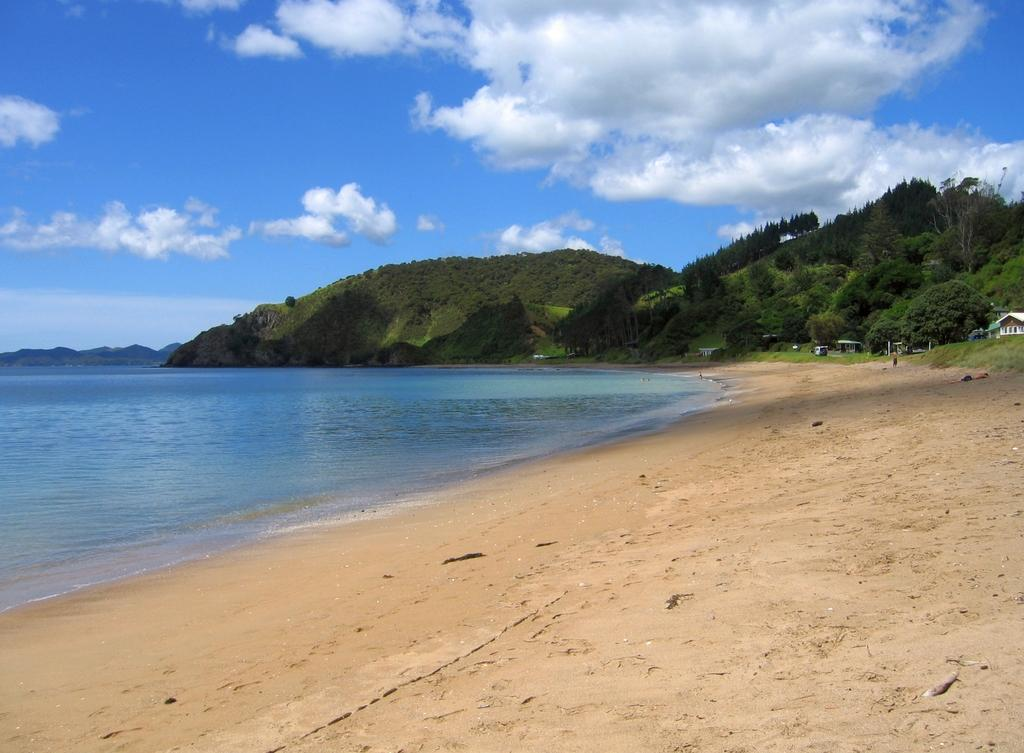What type of landscape is visible on the left side of the image? There is a sea on the left side of the image. What geographical feature is located in the center of the image? There are hills in the center of the image. What is visible at the top of the image? The sky is visible at the top of the image. What type of structures can be seen on the right side of the image? There are sheds on the right side of the image. What type of terrain is visible at the bottom of the image? There is a seashore at the bottom of the image. What type of lunch is being served on the seashore in the image? There is no lunch or any indication of food being served in the image; it only shows a sea, hills, sky, sheds, and a seashore. 